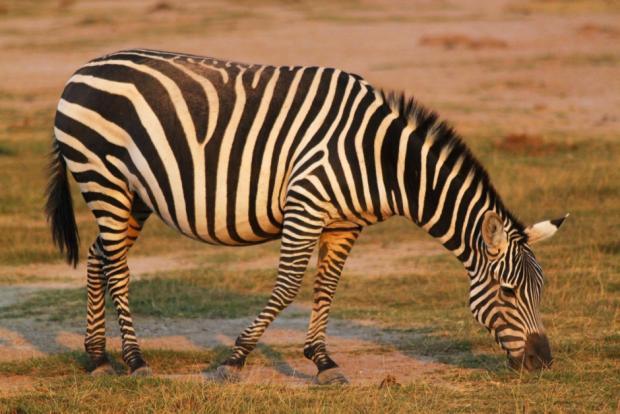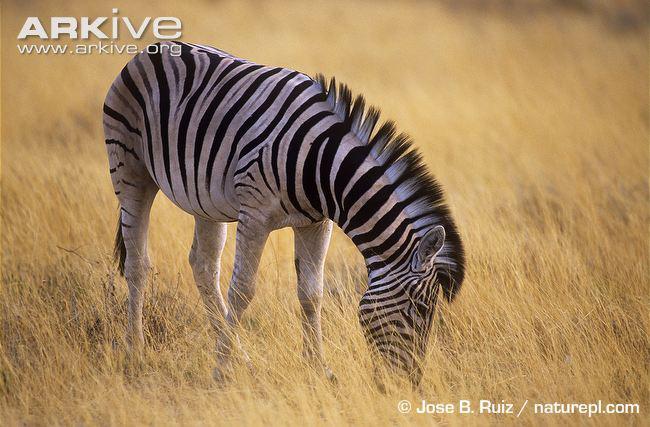The first image is the image on the left, the second image is the image on the right. Assess this claim about the two images: "A lion is pouncing on a zebra in one of the images.". Correct or not? Answer yes or no. No. The first image is the image on the left, the second image is the image on the right. Assess this claim about the two images: "There are animals fighting.". Correct or not? Answer yes or no. No. 